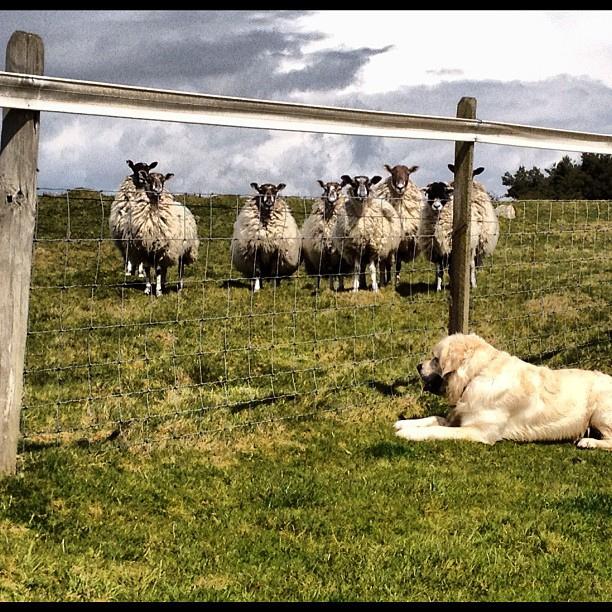How many sheep are in the picture?
Short answer required. 8. Are all the animals the same?
Be succinct. No. Could he be a herd dog?
Concise answer only. Yes. 